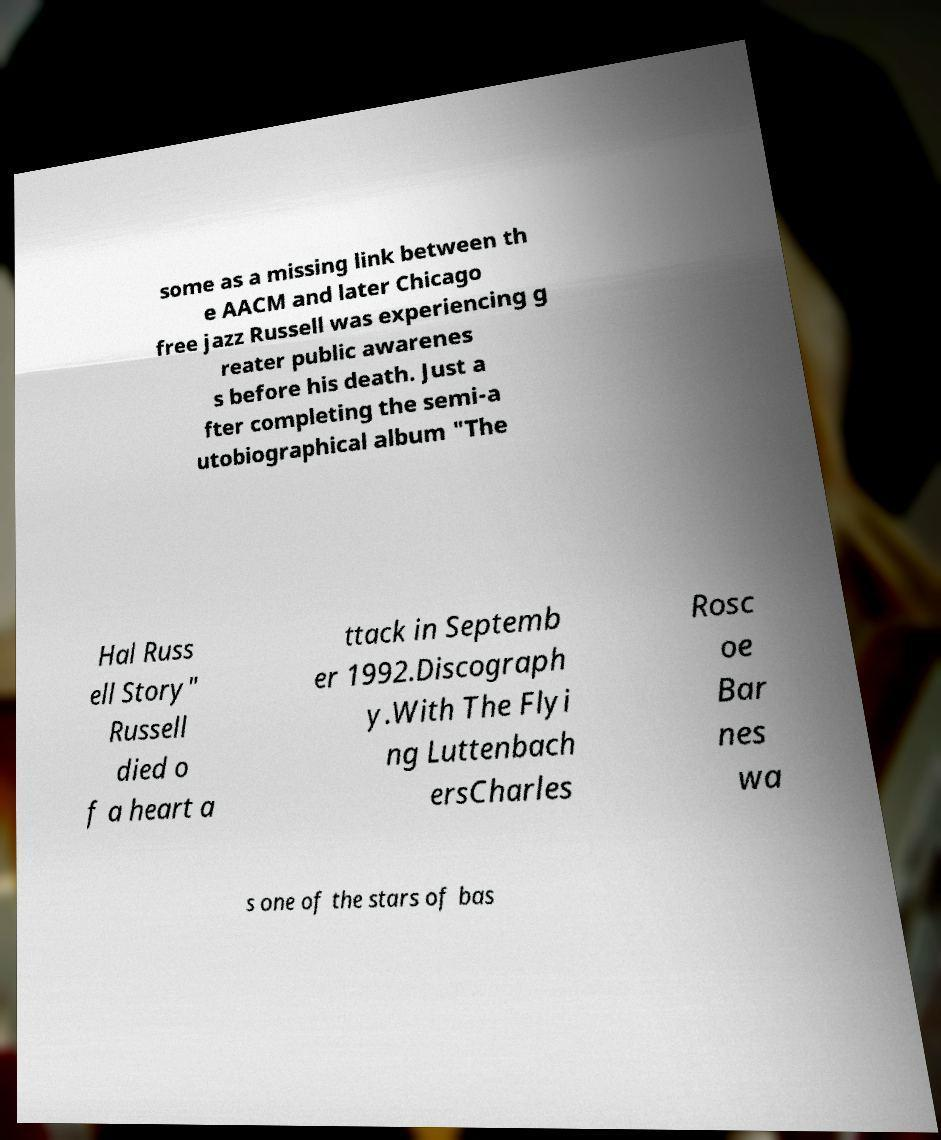I need the written content from this picture converted into text. Can you do that? some as a missing link between th e AACM and later Chicago free jazz Russell was experiencing g reater public awarenes s before his death. Just a fter completing the semi-a utobiographical album "The Hal Russ ell Story" Russell died o f a heart a ttack in Septemb er 1992.Discograph y.With The Flyi ng Luttenbach ersCharles Rosc oe Bar nes wa s one of the stars of bas 